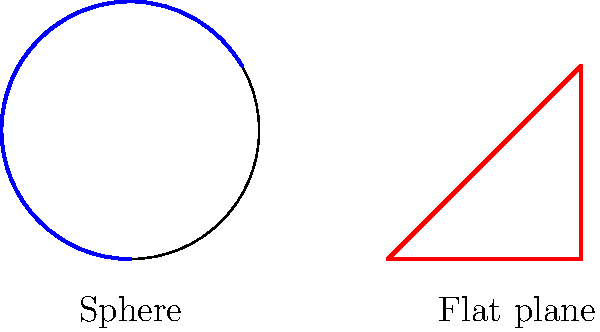In the context of optimizing system performance, consider the geometric properties of triangles on different surfaces. How does the sum of interior angles of a triangle on a sphere compare to that of a triangle on a flat plane, and how might this concept relate to efficient problem-solving in software development? To understand this concept and its relevance to software development, let's break it down step-by-step:

1. Flat plane triangle:
   - In Euclidean geometry, the sum of interior angles of a triangle is always $180°$ or $\pi$ radians.
   - This is constant regardless of the triangle's size or shape.

2. Spherical triangle:
   - On a sphere, the sum of interior angles of a triangle is always greater than $180°$.
   - The formula for the sum of angles in a spherical triangle is: $\alpha + \beta + \gamma - \pi = A$
     Where $\alpha$, $\beta$, and $\gamma$ are the angles, and $A$ is the area of the triangle on the unit sphere.

3. Comparison:
   - Spherical triangle sum > $180°$ > Flat triangle sum

4. Relevance to software development:
   - This concept illustrates how the same problem (defining a triangle) can have different solutions depending on the context (flat vs. curved surface).
   - In software development, this translates to considering the environment and constraints when designing solutions.
   - Just as the geometry changes based on the surface, software solutions may need to adapt to different platforms, architectures, or scaling requirements.

5. Efficiency implications:
   - Understanding these geometric differences can inspire more efficient problem-solving approaches.
   - For example, in routing algorithms for global networks, considering the Earth's curvature (spherical geometry) can lead to more efficient paths than assuming a flat surface.
   - This highlights the importance of choosing the right model or abstraction for a given problem to optimize performance.

6. Response time optimization:
   - By recognizing when traditional (flat) approaches may not be optimal, developers can explore alternative solutions that better fit the problem space.
   - This can lead to algorithms and data structures that more accurately represent the problem, potentially reducing computational complexity and improving response times.

Understanding this geometric concept encourages developers to think critically about the underlying assumptions in their problem space, potentially leading to more efficient and scalable solutions.
Answer: Spherical triangle sum > $180°$ > Flat triangle sum; inspires adaptive, context-aware problem-solving for optimized software solutions. 